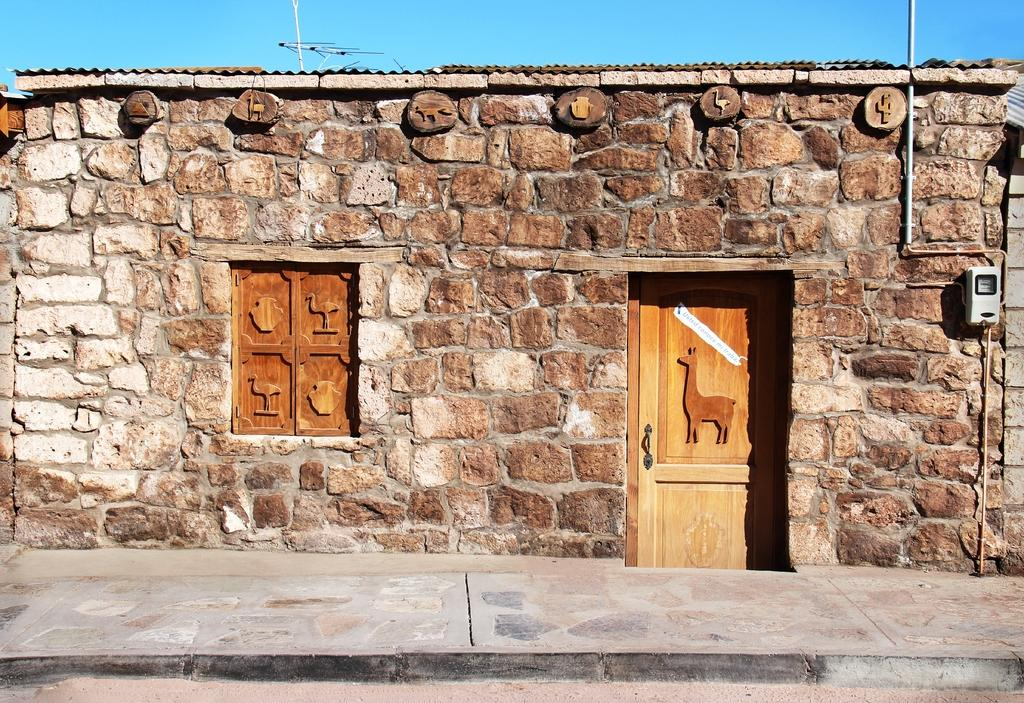What type of opening can be seen in the image? There is a door in the image. What allows natural light to enter the space in the image? There is a window in the image. What object in the image might be used for a specific function? There is a device in the image, which could be used for various purposes. What type of structure is present in the image? There is a wall in the image. What can be seen in the background of the image? The sky is visible in the background of the image. How many pigs are visible in the image? There are no pigs present in the image. What type of wound can be seen on the device in the image? There is no wound visible on any object in the image. 